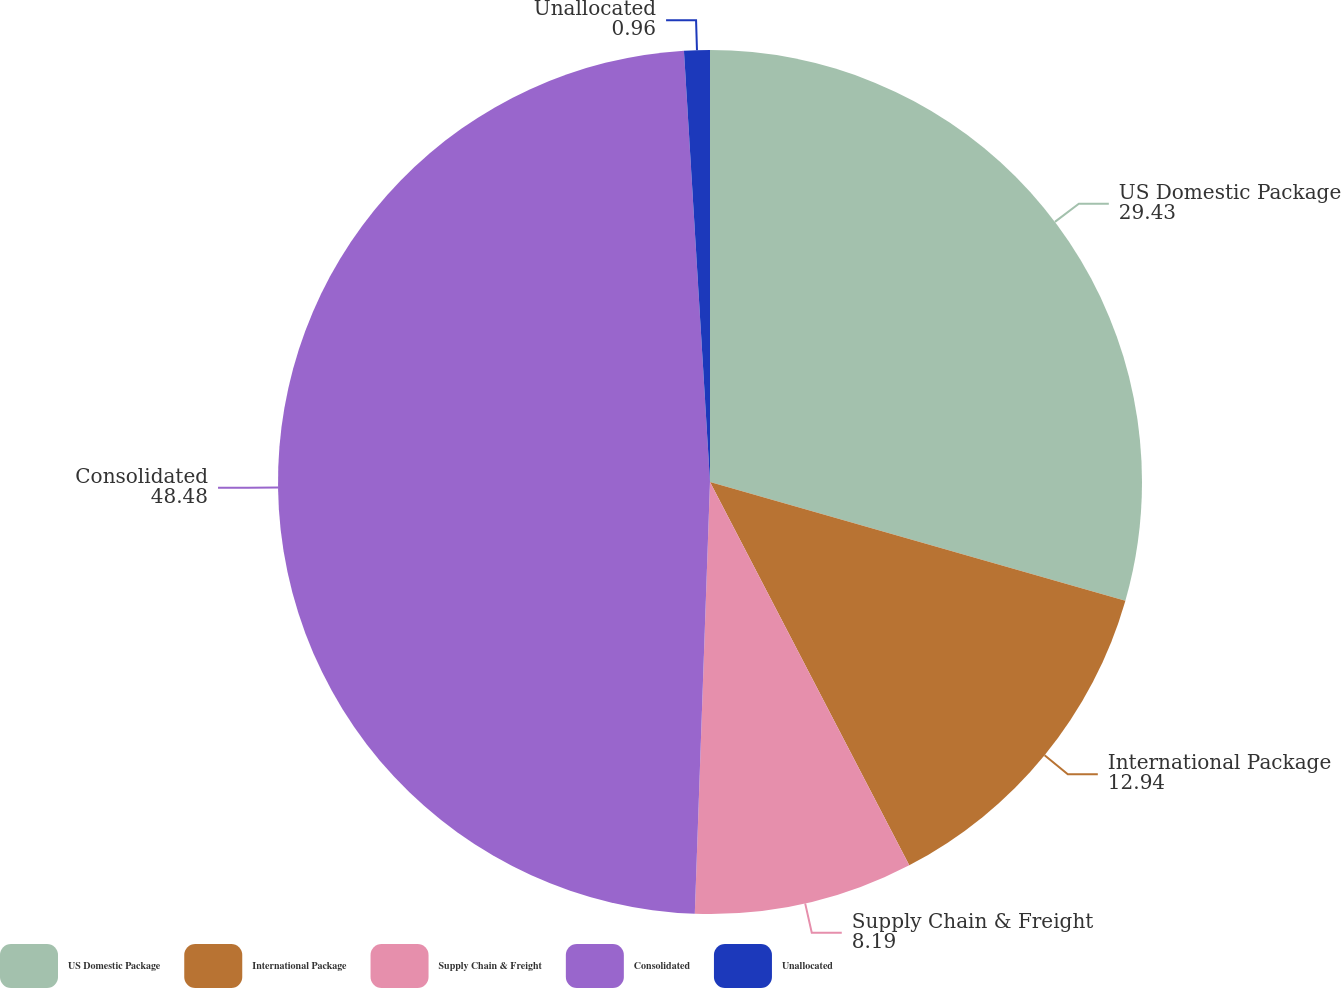Convert chart. <chart><loc_0><loc_0><loc_500><loc_500><pie_chart><fcel>US Domestic Package<fcel>International Package<fcel>Supply Chain & Freight<fcel>Consolidated<fcel>Unallocated<nl><fcel>29.43%<fcel>12.94%<fcel>8.19%<fcel>48.48%<fcel>0.96%<nl></chart> 